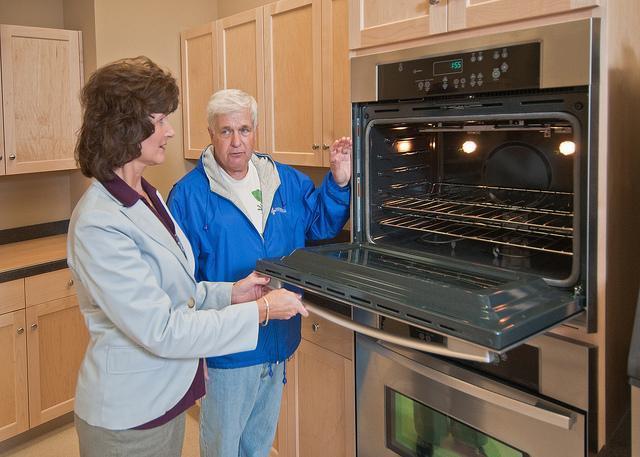How many people are in the picture?
Give a very brief answer. 2. How many ovens are in the photo?
Give a very brief answer. 2. 